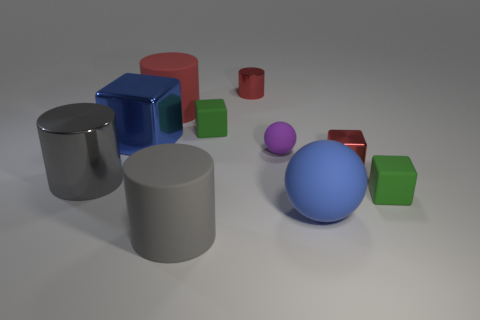Is the shape of the small purple object the same as the blue rubber thing?
Offer a terse response. Yes. What size is the metallic thing behind the large blue cube?
Provide a short and direct response. Small. Is the size of the blue matte sphere the same as the shiny cube that is to the right of the large blue shiny thing?
Give a very brief answer. No. Are there fewer large blue rubber spheres that are behind the gray metal thing than small gray cylinders?
Provide a succinct answer. No. There is another red object that is the same shape as the big red thing; what is it made of?
Your answer should be compact. Metal. There is a metal object that is both to the left of the tiny red metallic cylinder and behind the large gray metallic cylinder; what shape is it?
Your answer should be very brief. Cube. The blue thing that is the same material as the red cube is what shape?
Keep it short and to the point. Cube. There is a small green block on the left side of the tiny purple rubber thing; what is it made of?
Ensure brevity in your answer.  Rubber. There is a rubber sphere behind the gray shiny cylinder; is its size the same as the green cube in front of the small rubber ball?
Your answer should be compact. Yes. The large matte ball has what color?
Make the answer very short. Blue. 